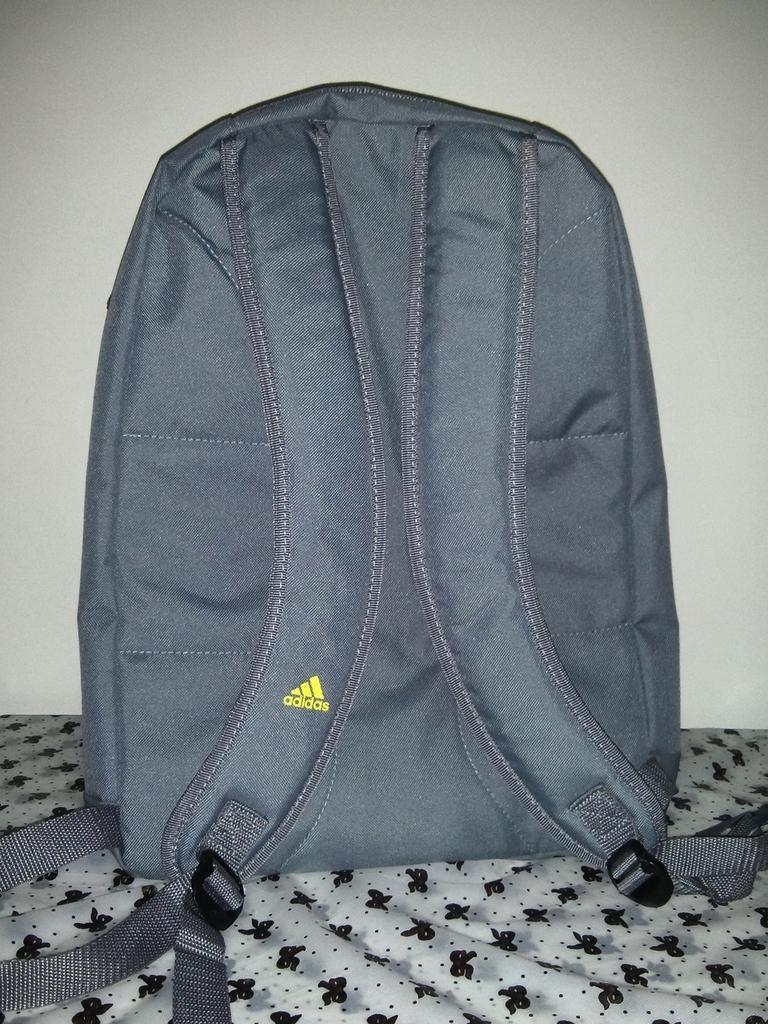Please provide a concise description of this image. This picture shows a backpack 